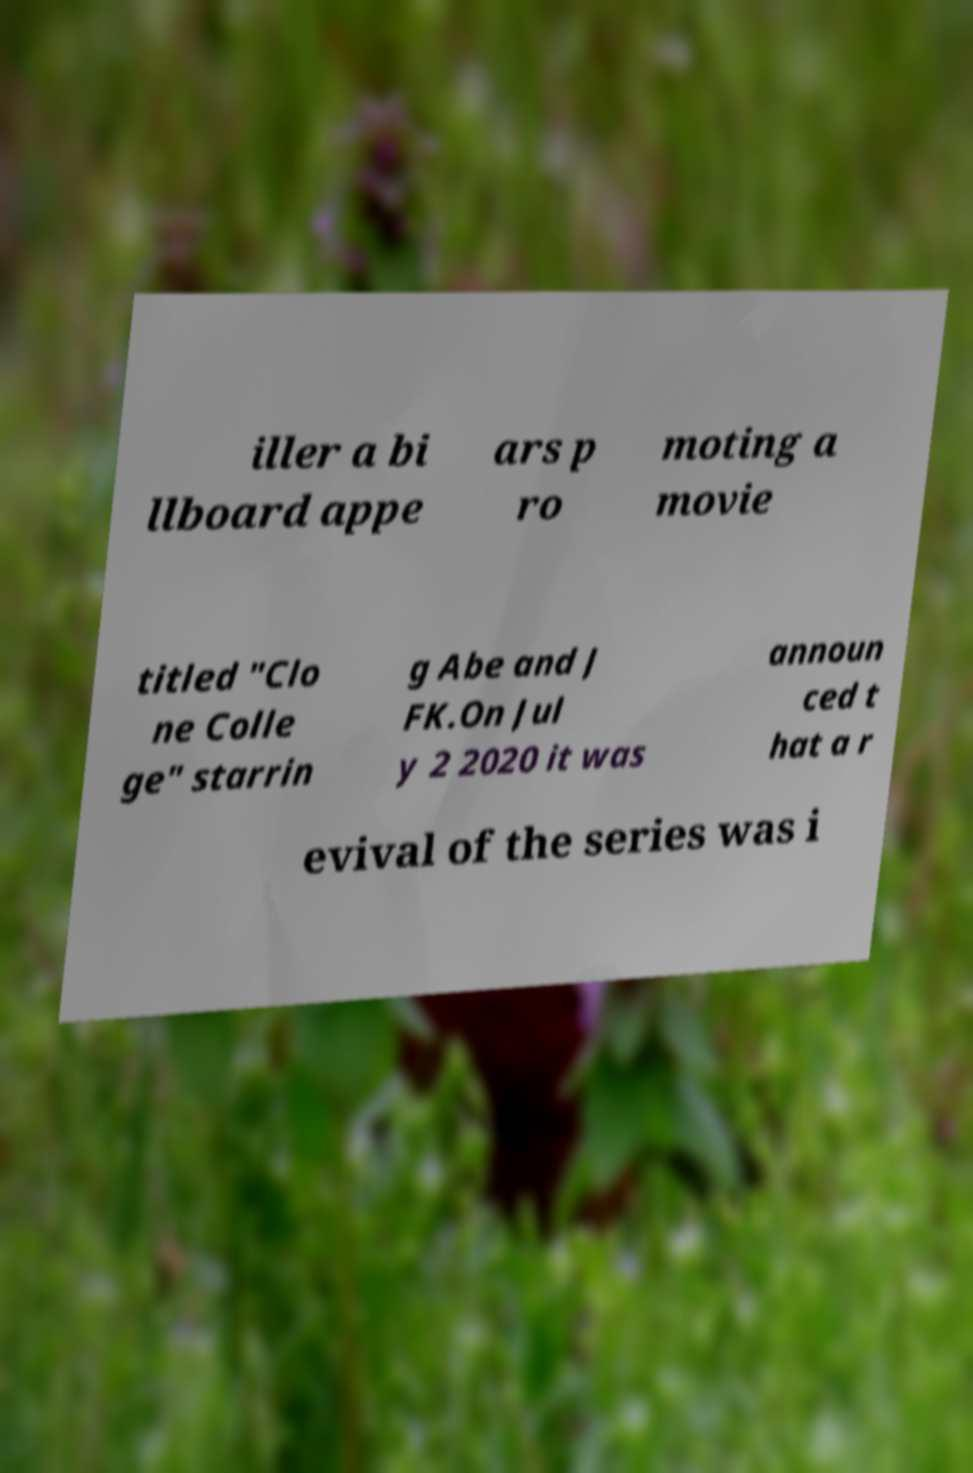There's text embedded in this image that I need extracted. Can you transcribe it verbatim? iller a bi llboard appe ars p ro moting a movie titled "Clo ne Colle ge" starrin g Abe and J FK.On Jul y 2 2020 it was announ ced t hat a r evival of the series was i 